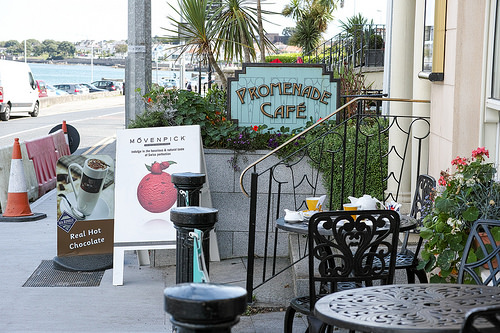<image>
Can you confirm if the traffic cone is on the sidewalk? Yes. Looking at the image, I can see the traffic cone is positioned on top of the sidewalk, with the sidewalk providing support. 